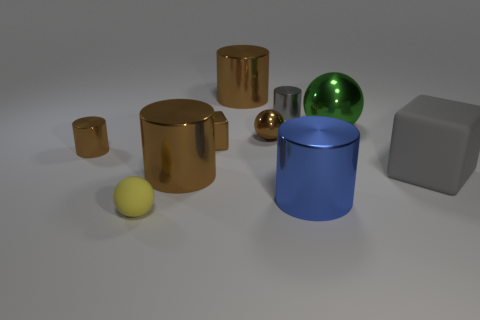How many cylinders are either green things or large gray matte objects?
Your answer should be compact. 0. How many big brown rubber balls are there?
Your answer should be very brief. 0. Do the blue object and the small brown object that is behind the tiny block have the same shape?
Ensure brevity in your answer.  No. The shiny sphere that is the same color as the metal cube is what size?
Your answer should be compact. Small. What number of things are large metal balls or small blocks?
Provide a short and direct response. 2. What is the shape of the tiny brown shiny thing to the left of the brown shiny thing in front of the gray matte object?
Provide a short and direct response. Cylinder. Is the shape of the big brown object that is behind the tiny brown metallic cylinder the same as  the small gray shiny thing?
Your response must be concise. Yes. There is a cube that is the same material as the big green ball; what size is it?
Ensure brevity in your answer.  Small. How many objects are brown things that are left of the small yellow rubber ball or blocks that are on the right side of the big blue cylinder?
Keep it short and to the point. 2. Are there the same number of tiny yellow matte objects in front of the big green ball and cubes that are behind the gray block?
Offer a terse response. Yes. 